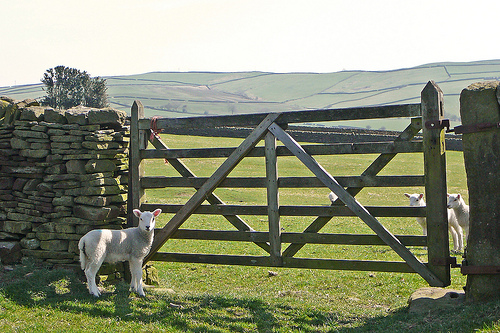How many sheep are there? There are three sheep in the image, positioned near a traditional wooden gate in what looks like a pastoral setting. This kind of environment is typical for sheep, providing them with ample space for grazing. 